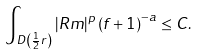Convert formula to latex. <formula><loc_0><loc_0><loc_500><loc_500>\int _ { D \left ( \frac { 1 } { 2 } r \right ) } \left | R m \right | ^ { p } \left ( f + 1 \right ) ^ { - a } \leq C .</formula> 